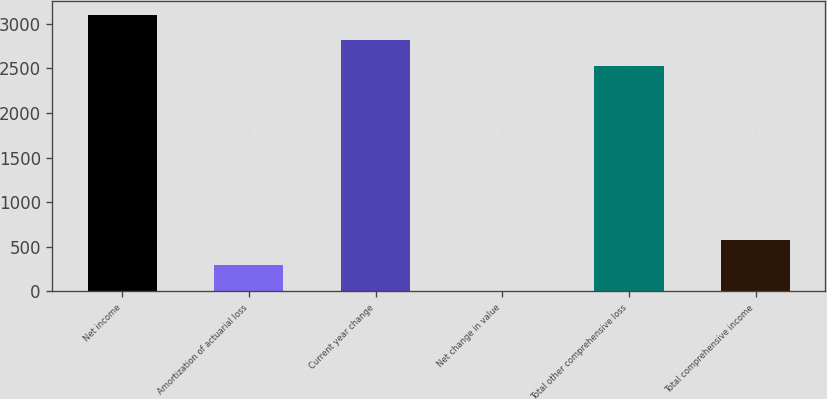Convert chart to OTSL. <chart><loc_0><loc_0><loc_500><loc_500><bar_chart><fcel>Net income<fcel>Amortization of actuarial loss<fcel>Current year change<fcel>Net change in value<fcel>Total other comprehensive loss<fcel>Total comprehensive income<nl><fcel>3102.8<fcel>290.9<fcel>2814.9<fcel>3<fcel>2527<fcel>578.8<nl></chart> 